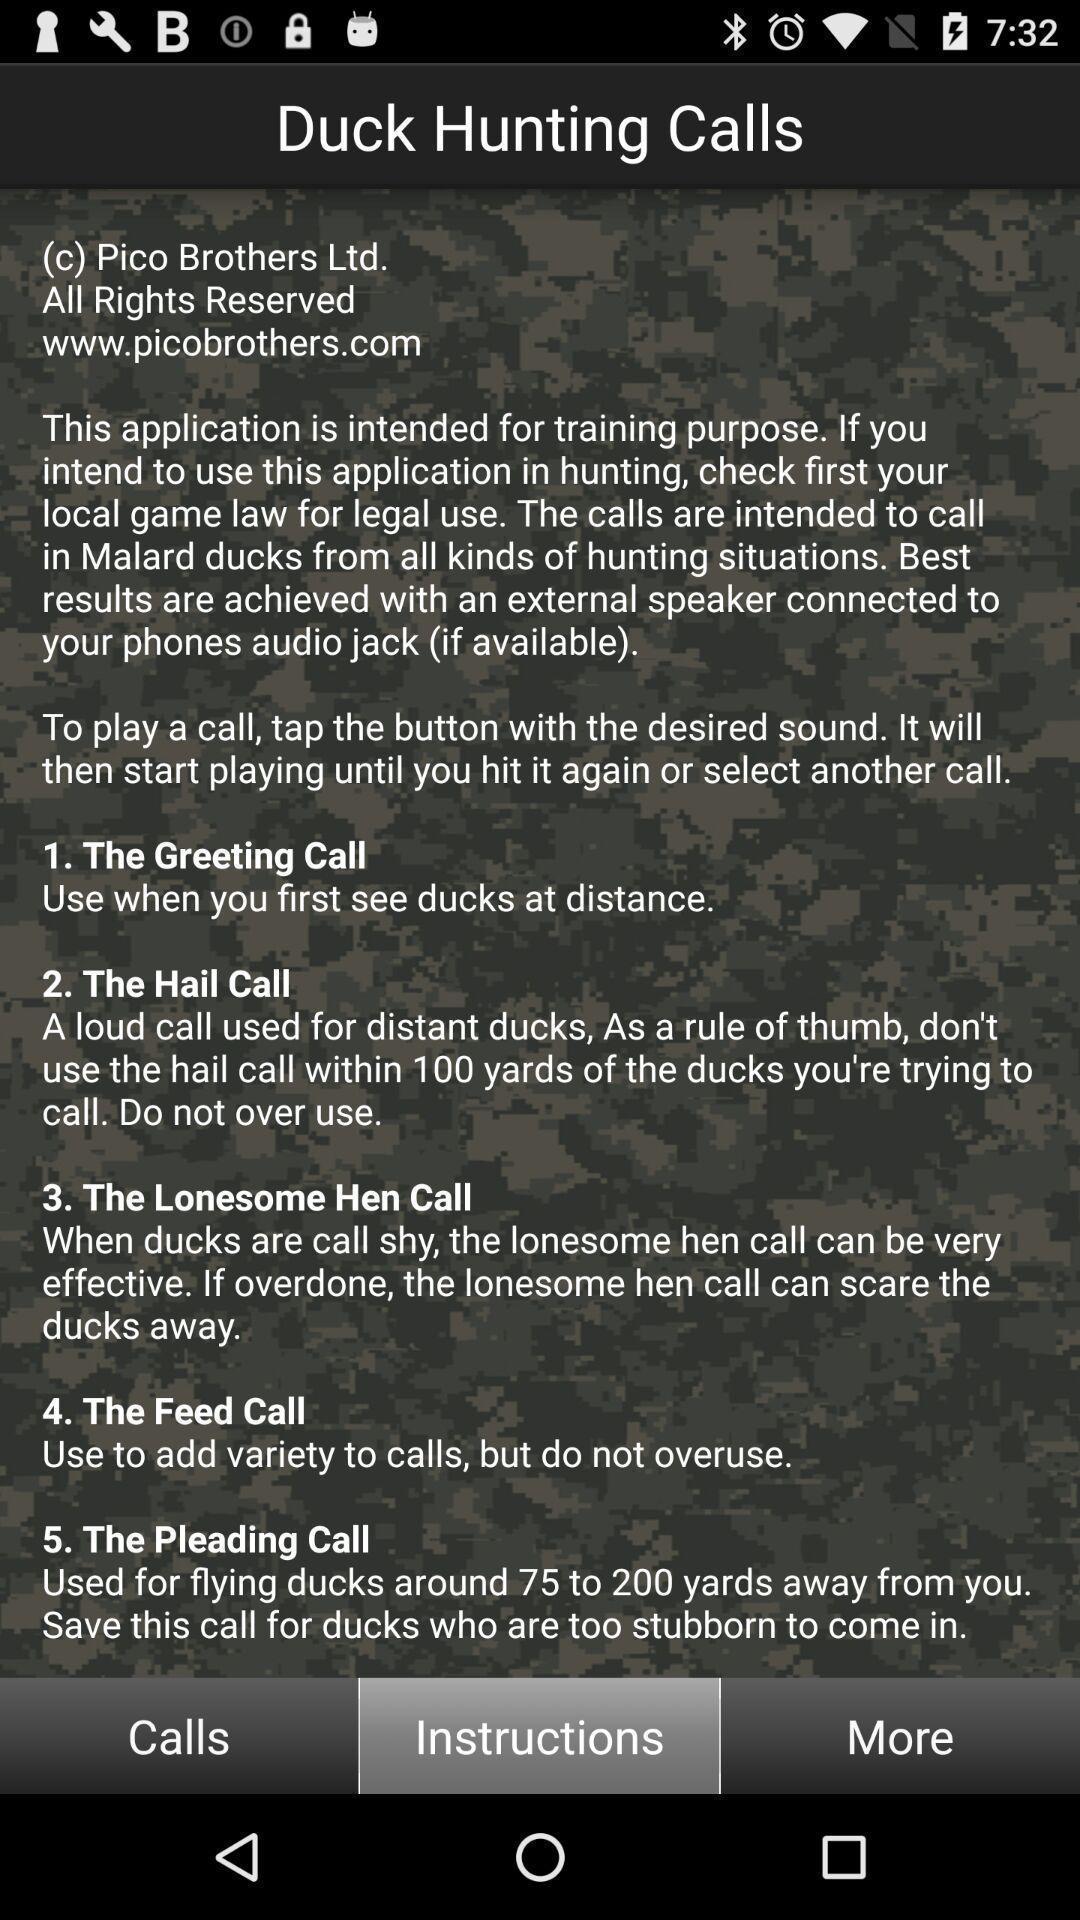Summarize the information in this screenshot. Page displaying instructions in application. 